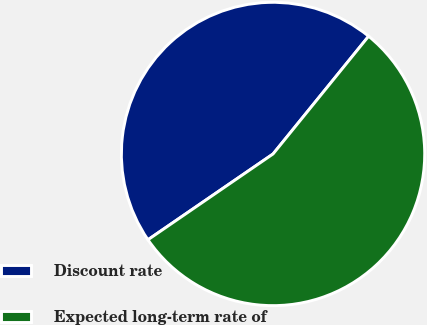<chart> <loc_0><loc_0><loc_500><loc_500><pie_chart><fcel>Discount rate<fcel>Expected long-term rate of<nl><fcel>45.42%<fcel>54.58%<nl></chart> 